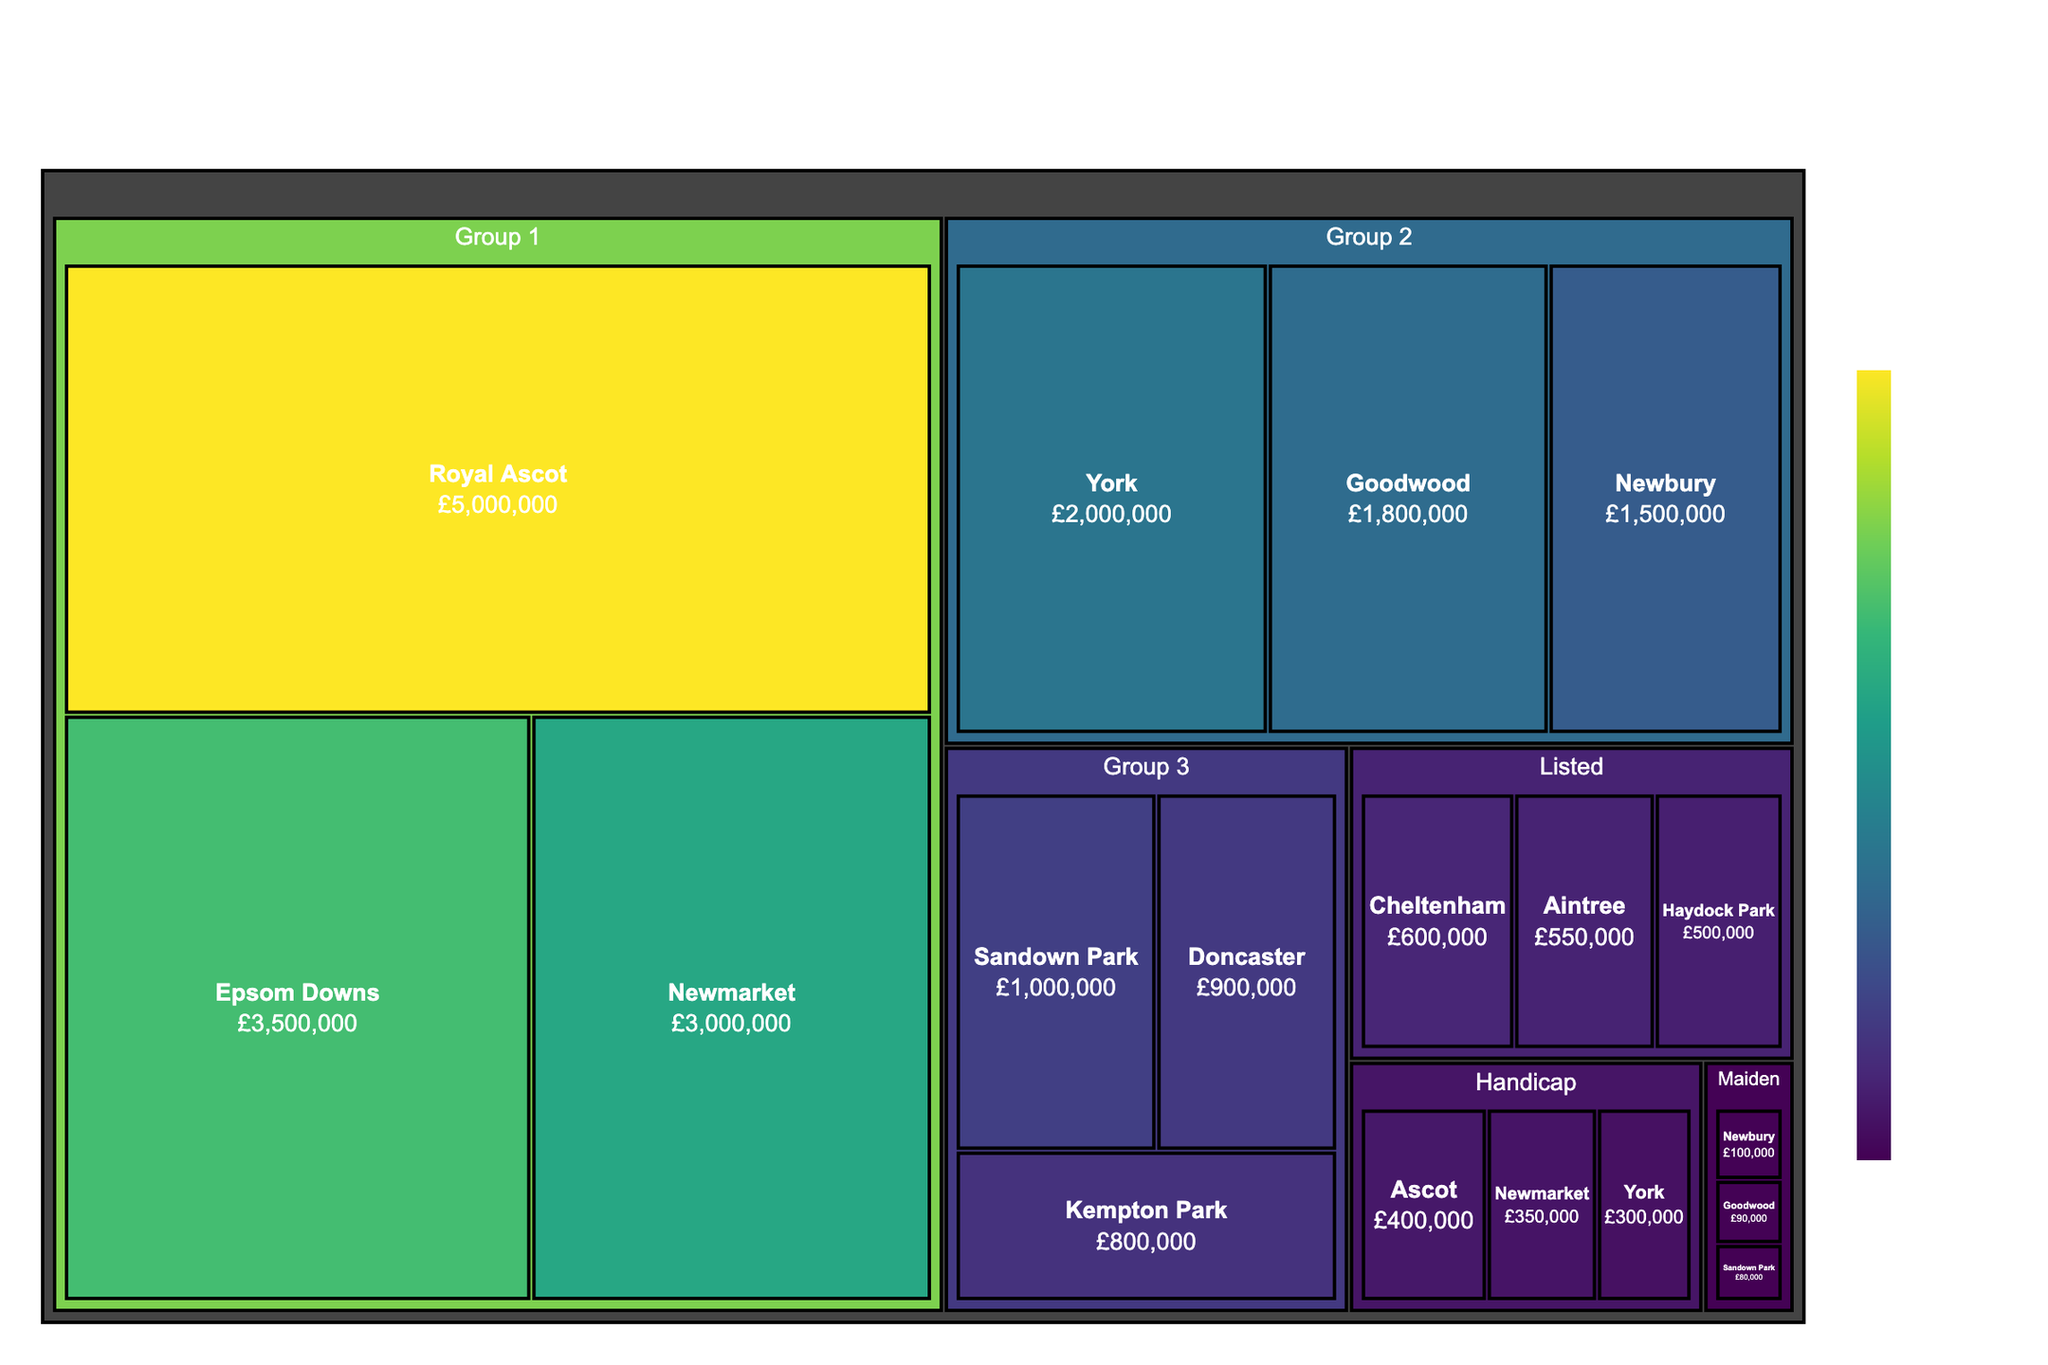Which race category has the highest overall prize money? The treemap shows each race category and associated tracks along with their respective prize money. The largest section (Group 1) represents the highest overall prize money. By summing the prize money within each category, Group 1 has the largest total.
Answer: Group 1 Which track within Group 1 has the highest prize money? Group 1 contains multiple tracks: Royal Ascot, Epsom Downs, and Newmarket. The treemap shows the prize money for each, and Royal Ascot has the highest.
Answer: Royal Ascot Compare the prize money between the top track in Group 2 and the top track in Handicap. Which is higher? The leading track in Group 2 is York with £2,000,000, and the leading track in Handicap is Ascot with £400,000. By comparing these amounts, York's prize money is higher.
Answer: York What is the total prize money for tracks categorized under Listed races? Listed category contains Cheltenham, Aintree, and Haydock Park. Summing their prize money: £600,000 + £550,000 + £500,000 = £1,650,000.
Answer: £1,650,000 Which race category overall has the lowest prize money? By summing the prize money for each category, the Maiden category has the lowest prize money: £100,000 + £90,000 + £80,000 = £270,000.
Answer: Maiden Which track has the smallest prize money in Group 3? Group 3 contains Sandown Park, Doncaster, and Kempton Park. The smallest prize money is for Kempton Park with £800,000.
Answer: Kempton Park How much more prize money does Royal Ascot in Group 1 have compared to Newmarket in the Handicap category? Royal Ascot in Group 1 has £5,000,000 and Newmarket in Handicap has £350,000. The difference is £5,000,000 - £350,000 = £4,650,000.
Answer: £4,650,000 What is the average prize money for tracks in the Group 2 category? Group 2 tracks are York, Goodwood, and Newbury. Their prize money is £2,000,000, £1,800,000, and £1,500,000, respectively. The average is (2,000,000 + 1,800,000 + 1,500,000) / 3 = £1,766,667.
Answer: £1,766,667 Which has higher prize money, the sum of all Handicap category tracks or the sum of all Listed category tracks? Handicap tracks' prize money is £400,000 (Ascot) + £350,000 (Newmarket) + £300,000 (York) = £1,050,000. Listed tracks' prize money is £600,000 (Cheltenham) + £550,000 (Aintree) + £500,000 (Haydock Park) = £1,650,000. Since £1,650,000 > £1,050,000, Listed category has higher prize money.
Answer: Listed category Which category predominantly features prize money close to or under £500,000? The Maiden and Handicap categories have prize money amounts predominantly close to or under £500,000 for their respective tracks.
Answer: Maiden and Handicap 